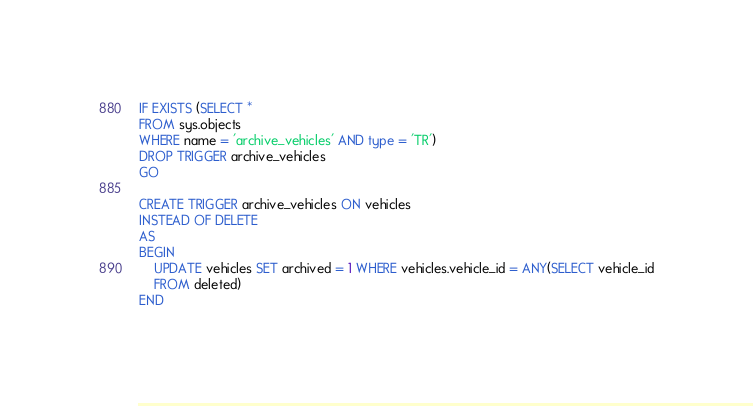Convert code to text. <code><loc_0><loc_0><loc_500><loc_500><_SQL_>IF EXISTS (SELECT *
FROM sys.objects
WHERE name = 'archive_vehicles' AND type = 'TR')
DROP TRIGGER archive_vehicles
GO

CREATE TRIGGER archive_vehicles ON vehicles
INSTEAD OF DELETE
AS 
BEGIN
    UPDATE vehicles SET archived = 1 WHERE vehicles.vehicle_id = ANY(SELECT vehicle_id
    FROM deleted)
END</code> 